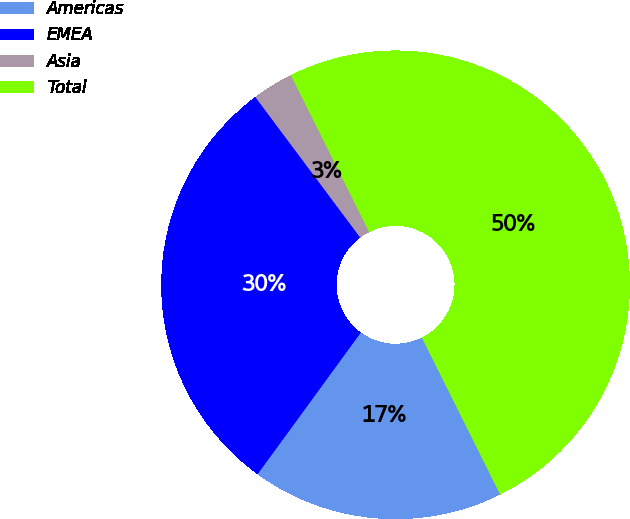Convert chart. <chart><loc_0><loc_0><loc_500><loc_500><pie_chart><fcel>Americas<fcel>EMEA<fcel>Asia<fcel>Total<nl><fcel>17.39%<fcel>29.77%<fcel>2.84%<fcel>50.0%<nl></chart> 